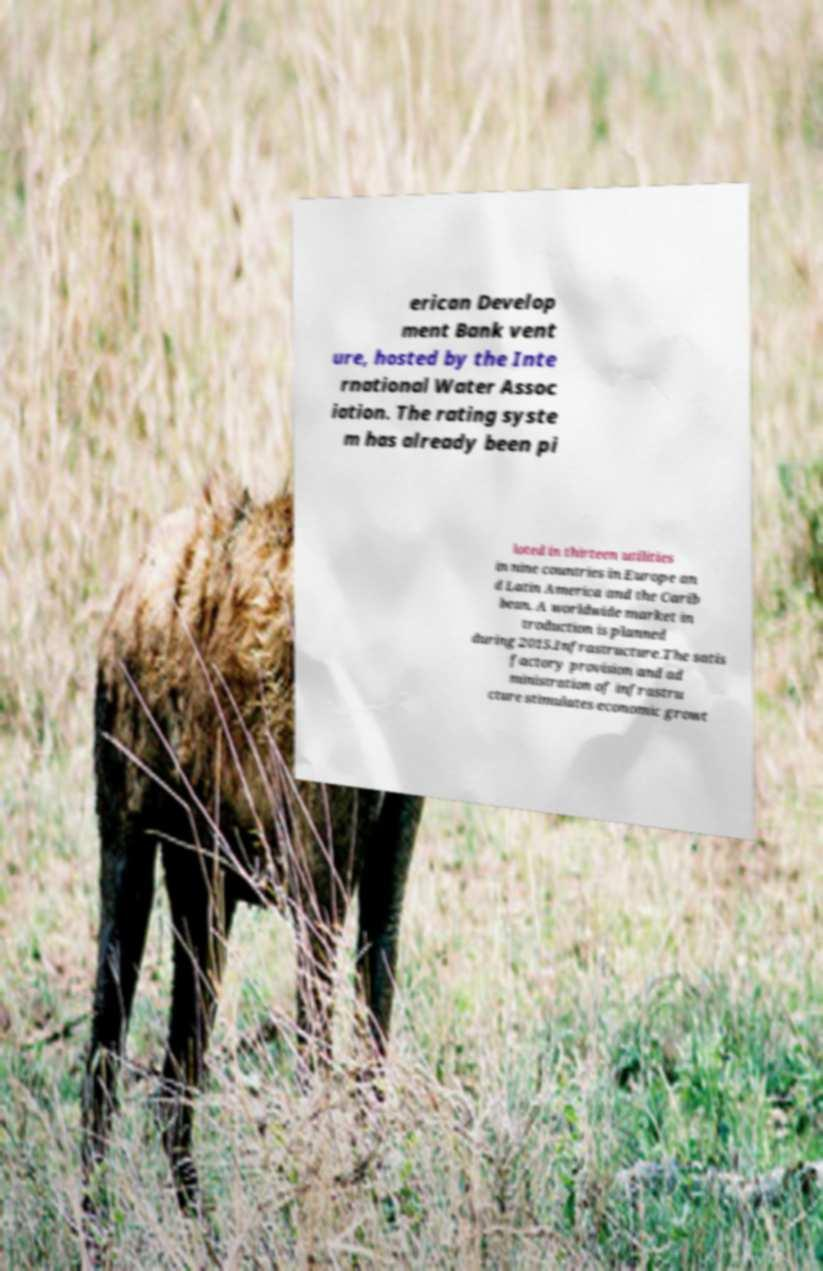Could you assist in decoding the text presented in this image and type it out clearly? erican Develop ment Bank vent ure, hosted by the Inte rnational Water Assoc iation. The rating syste m has already been pi loted in thirteen utilities in nine countries in Europe an d Latin America and the Carib bean. A worldwide market in troduction is planned during 2015.Infrastructure.The satis factory provision and ad ministration of infrastru cture stimulates economic growt 